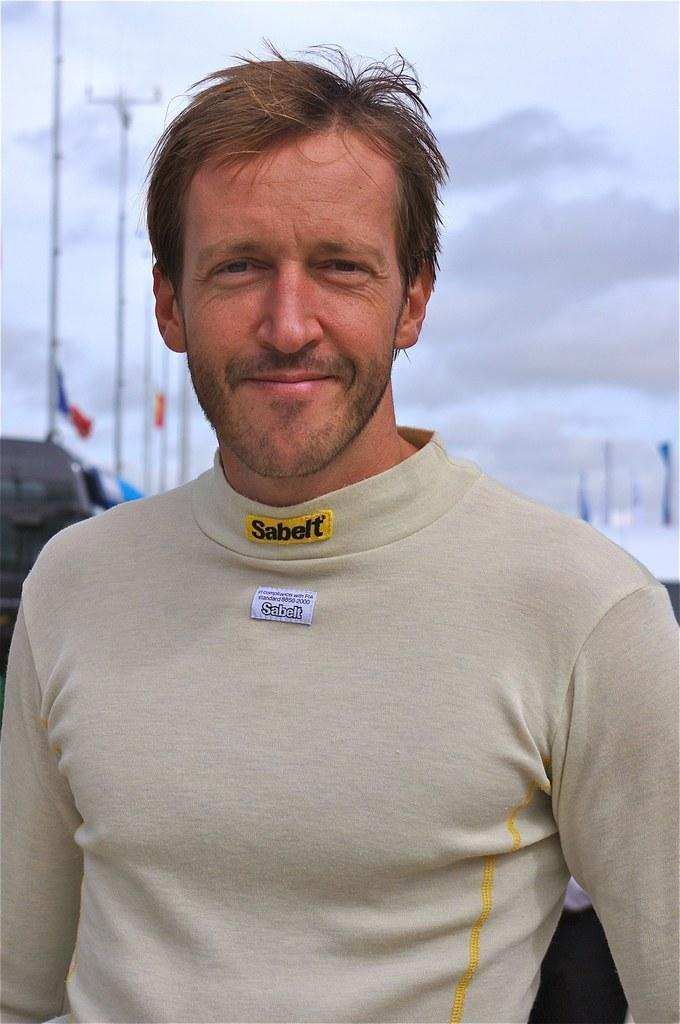What is the main subject of the image? There is a man in the image. What is the man wearing? The man is wearing a cream-colored t-shirt. What is the man's facial expression? The man is smiling. What can be seen in the background of the image? There are poles and flags in the background of the image. What is the condition of the sky in the image? The sky is covered with clouds. What type of flame can be seen coming from the man's t-shirt in the image? There is no flame present in the image; the man is wearing a cream-colored t-shirt. What acoustics are being used to amplify the man's voice in the image? There is no mention of any acoustics or voice amplification in the image; the man is simply smiling. 